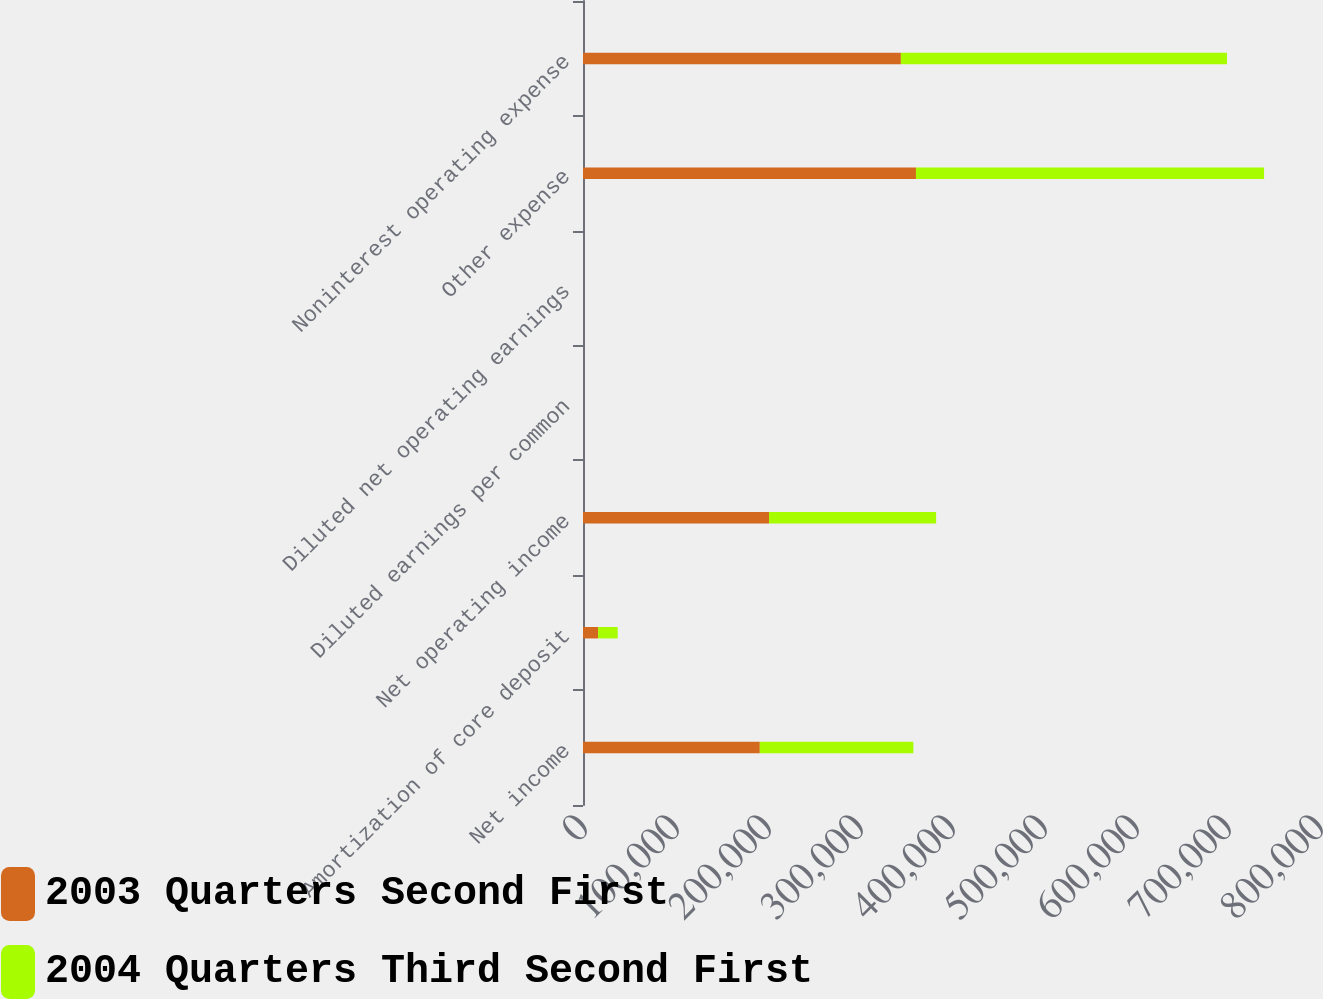<chart> <loc_0><loc_0><loc_500><loc_500><stacked_bar_chart><ecel><fcel>Net income<fcel>Amortization of core deposit<fcel>Net operating income<fcel>Diluted earnings per common<fcel>Diluted net operating earnings<fcel>Other expense<fcel>Noninterest operating expense<nl><fcel>2003 Quarters Second First<fcel>192205<fcel>16393<fcel>202215<fcel>1.62<fcel>1.7<fcel>361922<fcel>345529<nl><fcel>2004 Quarters Third Second First<fcel>166901<fcel>21345<fcel>181594<fcel>1.35<fcel>1.47<fcel>378355<fcel>354477<nl></chart> 